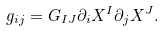Convert formula to latex. <formula><loc_0><loc_0><loc_500><loc_500>g _ { i j } = G _ { I J } \partial _ { i } X ^ { I } \partial _ { j } X ^ { J } .</formula> 